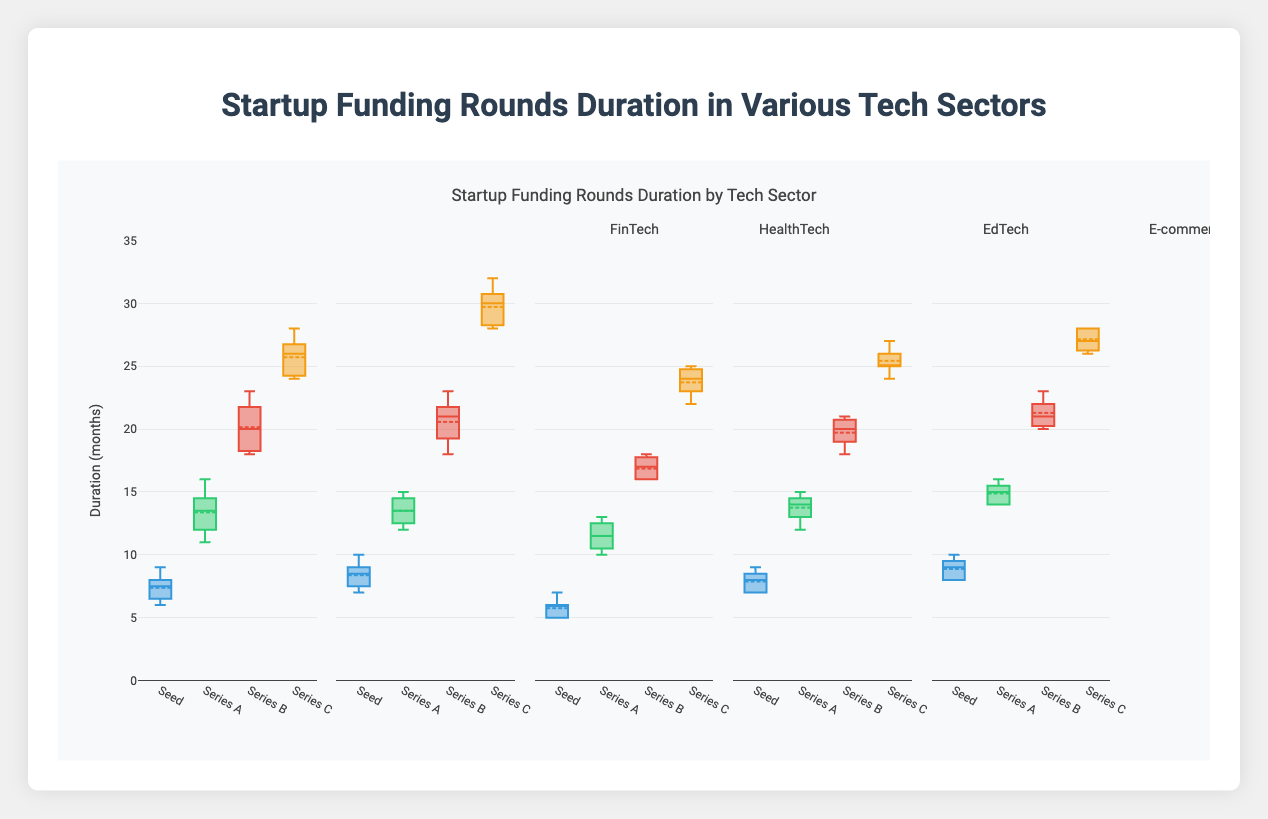What is the median duration for HealthTech Series B funding rounds? To find the median, list the Series B durations for HealthTech: [18, 19, 20, 21, 21, 22, 23]. The middle value is 21.
Answer: 21 What sector has the longest duration at Series C? Look at the maximum values for Series C across all sectors. HealthTech has the highest maximum value at 32 months.
Answer: HealthTech How do the durations for Seed rounds compare between EdTech and E-commerce? Compare the box plots for Seed rounds in EdTech and E-commerce. EdTech typically has lower durations (5-7 months) compared to E-commerce (7-9 months).
Answer: EdTech has shorter durations Which sector has the widest interquartile range (IQR) for Series A rounds? The IQR is the range between the 25th and 75th percentiles. By visually comparing, FinTech has the widest IQR for Series A rounds.
Answer: FinTech What is the average duration for AI & Machine Learning Series C rounds? List AI & Machine Learning Series C durations: [26, 27, 28, 26, 27, 28, 28]. Sum these durations (190) and divide by the number of data points (7).
Answer: 27.14 Is there a sector where the median duration for Seed rounds is 8 months? Look at the box plots for Seed rounds across all sectors. Both FinTech and E-commerce have a median duration of 8 months for Seed rounds.
Answer: Yes Which sector has the smallest range for Seed funding duration? The range is the difference between the smallest and largest values. EdTech has the smallest range for Seed funding with values between 5 and 7 months.
Answer: EdTech What is the trend in duration from Seed to Series C in HealthTech? The box plots show increasing durations: Seed (7-10), Series A (12-15), Series B (18-23), Series C (28-32).
Answer: Increasing How does the median Series A duration in E-commerce compare to the median Series A duration in EdTech? The median Series A duration in E-commerce is 14 months, while in EdTech, it is 12 months.
Answer: E-commerce has a longer median What is the interquartile range for FinTech Series B rounds? The IQR is the range between the 25th (18) and 75th (21) percentiles for FinTech Series B. The IQR is 21 - 18 = 3 months.
Answer: 3 months 